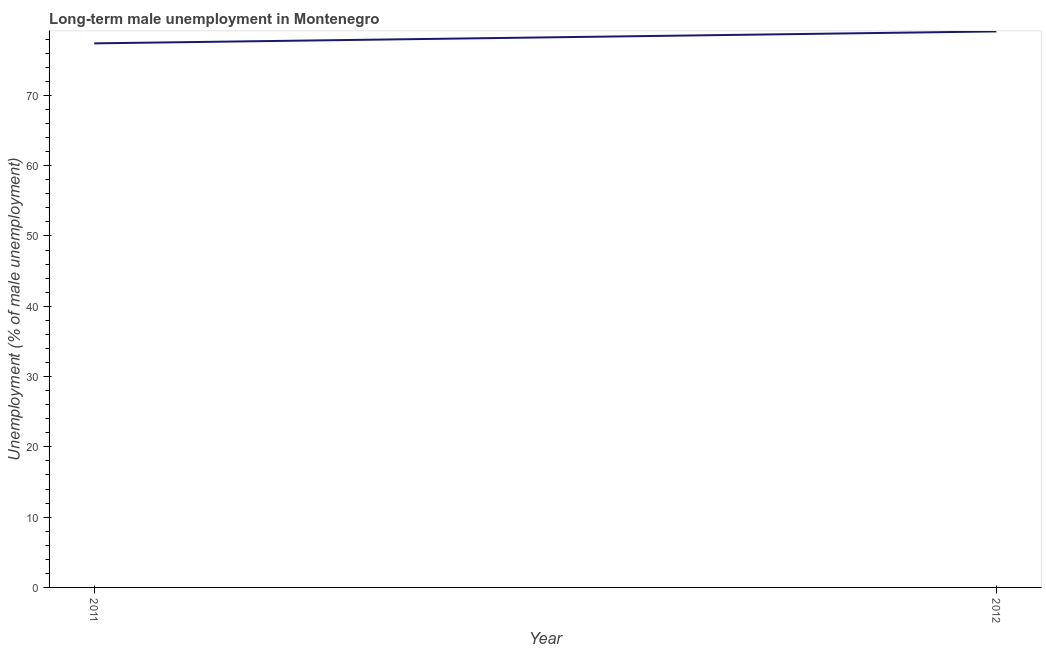What is the long-term male unemployment in 2011?
Offer a terse response. 77.4. Across all years, what is the maximum long-term male unemployment?
Ensure brevity in your answer.  79.1. Across all years, what is the minimum long-term male unemployment?
Your response must be concise. 77.4. In which year was the long-term male unemployment minimum?
Your answer should be very brief. 2011. What is the sum of the long-term male unemployment?
Offer a terse response. 156.5. What is the difference between the long-term male unemployment in 2011 and 2012?
Ensure brevity in your answer.  -1.7. What is the average long-term male unemployment per year?
Make the answer very short. 78.25. What is the median long-term male unemployment?
Give a very brief answer. 78.25. In how many years, is the long-term male unemployment greater than 44 %?
Offer a very short reply. 2. Do a majority of the years between 2011 and 2012 (inclusive) have long-term male unemployment greater than 54 %?
Provide a short and direct response. Yes. What is the ratio of the long-term male unemployment in 2011 to that in 2012?
Your answer should be very brief. 0.98. Does the long-term male unemployment monotonically increase over the years?
Your answer should be very brief. Yes. How many lines are there?
Your response must be concise. 1. Does the graph contain grids?
Offer a very short reply. No. What is the title of the graph?
Give a very brief answer. Long-term male unemployment in Montenegro. What is the label or title of the Y-axis?
Ensure brevity in your answer.  Unemployment (% of male unemployment). What is the Unemployment (% of male unemployment) of 2011?
Ensure brevity in your answer.  77.4. What is the Unemployment (% of male unemployment) of 2012?
Make the answer very short. 79.1. What is the difference between the Unemployment (% of male unemployment) in 2011 and 2012?
Offer a very short reply. -1.7. What is the ratio of the Unemployment (% of male unemployment) in 2011 to that in 2012?
Your answer should be very brief. 0.98. 